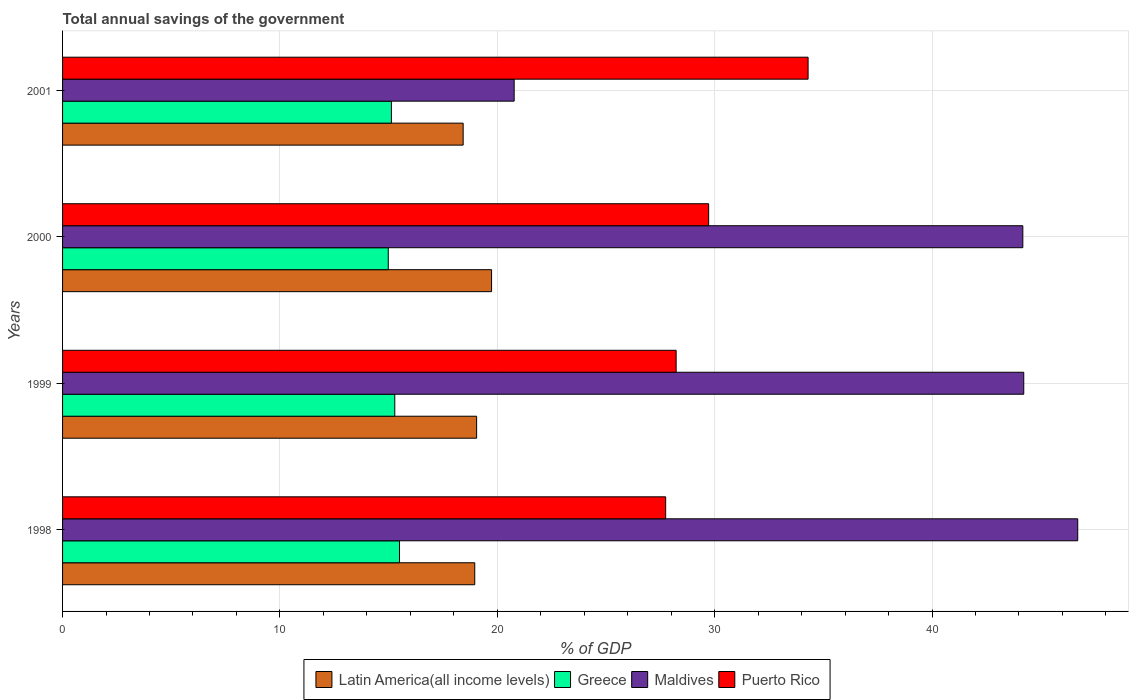How many groups of bars are there?
Your answer should be compact. 4. Are the number of bars per tick equal to the number of legend labels?
Give a very brief answer. Yes. How many bars are there on the 2nd tick from the bottom?
Offer a terse response. 4. What is the label of the 4th group of bars from the top?
Offer a terse response. 1998. What is the total annual savings of the government in Greece in 2000?
Your answer should be very brief. 14.98. Across all years, what is the maximum total annual savings of the government in Latin America(all income levels)?
Ensure brevity in your answer.  19.74. Across all years, what is the minimum total annual savings of the government in Latin America(all income levels)?
Your response must be concise. 18.43. What is the total total annual savings of the government in Greece in the graph?
Your response must be concise. 60.9. What is the difference between the total annual savings of the government in Puerto Rico in 1998 and that in 2000?
Provide a succinct answer. -1.98. What is the difference between the total annual savings of the government in Maldives in 1998 and the total annual savings of the government in Puerto Rico in 2001?
Offer a very short reply. 12.41. What is the average total annual savings of the government in Greece per year?
Your answer should be compact. 15.22. In the year 2000, what is the difference between the total annual savings of the government in Maldives and total annual savings of the government in Latin America(all income levels)?
Give a very brief answer. 24.44. What is the ratio of the total annual savings of the government in Greece in 1999 to that in 2000?
Make the answer very short. 1.02. Is the difference between the total annual savings of the government in Maldives in 1999 and 2001 greater than the difference between the total annual savings of the government in Latin America(all income levels) in 1999 and 2001?
Offer a very short reply. Yes. What is the difference between the highest and the second highest total annual savings of the government in Puerto Rico?
Provide a succinct answer. 4.57. What is the difference between the highest and the lowest total annual savings of the government in Puerto Rico?
Provide a short and direct response. 6.55. Is it the case that in every year, the sum of the total annual savings of the government in Latin America(all income levels) and total annual savings of the government in Maldives is greater than the sum of total annual savings of the government in Puerto Rico and total annual savings of the government in Greece?
Offer a terse response. Yes. What does the 3rd bar from the top in 2000 represents?
Provide a succinct answer. Greece. What does the 1st bar from the bottom in 1999 represents?
Give a very brief answer. Latin America(all income levels). Is it the case that in every year, the sum of the total annual savings of the government in Greece and total annual savings of the government in Puerto Rico is greater than the total annual savings of the government in Maldives?
Offer a terse response. No. How many bars are there?
Give a very brief answer. 16. Are all the bars in the graph horizontal?
Provide a succinct answer. Yes. How many years are there in the graph?
Ensure brevity in your answer.  4. Are the values on the major ticks of X-axis written in scientific E-notation?
Your answer should be very brief. No. Does the graph contain any zero values?
Give a very brief answer. No. Where does the legend appear in the graph?
Your response must be concise. Bottom center. What is the title of the graph?
Provide a short and direct response. Total annual savings of the government. What is the label or title of the X-axis?
Offer a very short reply. % of GDP. What is the % of GDP of Latin America(all income levels) in 1998?
Make the answer very short. 18.96. What is the % of GDP in Greece in 1998?
Provide a succinct answer. 15.5. What is the % of GDP in Maldives in 1998?
Provide a succinct answer. 46.7. What is the % of GDP of Puerto Rico in 1998?
Your answer should be compact. 27.75. What is the % of GDP in Latin America(all income levels) in 1999?
Your answer should be compact. 19.05. What is the % of GDP in Greece in 1999?
Ensure brevity in your answer.  15.28. What is the % of GDP of Maldives in 1999?
Ensure brevity in your answer.  44.22. What is the % of GDP in Puerto Rico in 1999?
Keep it short and to the point. 28.23. What is the % of GDP of Latin America(all income levels) in 2000?
Your response must be concise. 19.74. What is the % of GDP in Greece in 2000?
Offer a terse response. 14.98. What is the % of GDP in Maldives in 2000?
Your answer should be compact. 44.18. What is the % of GDP of Puerto Rico in 2000?
Keep it short and to the point. 29.72. What is the % of GDP in Latin America(all income levels) in 2001?
Offer a terse response. 18.43. What is the % of GDP of Greece in 2001?
Offer a terse response. 15.13. What is the % of GDP in Maldives in 2001?
Give a very brief answer. 20.78. What is the % of GDP of Puerto Rico in 2001?
Make the answer very short. 34.3. Across all years, what is the maximum % of GDP in Latin America(all income levels)?
Provide a succinct answer. 19.74. Across all years, what is the maximum % of GDP of Greece?
Keep it short and to the point. 15.5. Across all years, what is the maximum % of GDP of Maldives?
Keep it short and to the point. 46.7. Across all years, what is the maximum % of GDP of Puerto Rico?
Give a very brief answer. 34.3. Across all years, what is the minimum % of GDP in Latin America(all income levels)?
Offer a terse response. 18.43. Across all years, what is the minimum % of GDP in Greece?
Provide a succinct answer. 14.98. Across all years, what is the minimum % of GDP in Maldives?
Provide a short and direct response. 20.78. Across all years, what is the minimum % of GDP of Puerto Rico?
Offer a terse response. 27.75. What is the total % of GDP of Latin America(all income levels) in the graph?
Your answer should be compact. 76.18. What is the total % of GDP of Greece in the graph?
Offer a very short reply. 60.9. What is the total % of GDP of Maldives in the graph?
Give a very brief answer. 155.88. What is the total % of GDP in Puerto Rico in the graph?
Make the answer very short. 120. What is the difference between the % of GDP of Latin America(all income levels) in 1998 and that in 1999?
Your answer should be very brief. -0.09. What is the difference between the % of GDP in Greece in 1998 and that in 1999?
Offer a terse response. 0.22. What is the difference between the % of GDP in Maldives in 1998 and that in 1999?
Offer a very short reply. 2.48. What is the difference between the % of GDP in Puerto Rico in 1998 and that in 1999?
Offer a very short reply. -0.48. What is the difference between the % of GDP in Latin America(all income levels) in 1998 and that in 2000?
Give a very brief answer. -0.77. What is the difference between the % of GDP in Greece in 1998 and that in 2000?
Offer a very short reply. 0.52. What is the difference between the % of GDP in Maldives in 1998 and that in 2000?
Provide a succinct answer. 2.53. What is the difference between the % of GDP in Puerto Rico in 1998 and that in 2000?
Make the answer very short. -1.98. What is the difference between the % of GDP in Latin America(all income levels) in 1998 and that in 2001?
Make the answer very short. 0.53. What is the difference between the % of GDP of Greece in 1998 and that in 2001?
Ensure brevity in your answer.  0.37. What is the difference between the % of GDP of Maldives in 1998 and that in 2001?
Give a very brief answer. 25.93. What is the difference between the % of GDP in Puerto Rico in 1998 and that in 2001?
Keep it short and to the point. -6.55. What is the difference between the % of GDP of Latin America(all income levels) in 1999 and that in 2000?
Your answer should be very brief. -0.69. What is the difference between the % of GDP in Greece in 1999 and that in 2000?
Your answer should be very brief. 0.3. What is the difference between the % of GDP of Maldives in 1999 and that in 2000?
Your answer should be compact. 0.04. What is the difference between the % of GDP in Puerto Rico in 1999 and that in 2000?
Give a very brief answer. -1.5. What is the difference between the % of GDP in Latin America(all income levels) in 1999 and that in 2001?
Make the answer very short. 0.62. What is the difference between the % of GDP of Greece in 1999 and that in 2001?
Your answer should be compact. 0.16. What is the difference between the % of GDP in Maldives in 1999 and that in 2001?
Provide a succinct answer. 23.44. What is the difference between the % of GDP of Puerto Rico in 1999 and that in 2001?
Keep it short and to the point. -6.07. What is the difference between the % of GDP of Latin America(all income levels) in 2000 and that in 2001?
Make the answer very short. 1.31. What is the difference between the % of GDP of Greece in 2000 and that in 2001?
Your response must be concise. -0.14. What is the difference between the % of GDP of Maldives in 2000 and that in 2001?
Make the answer very short. 23.4. What is the difference between the % of GDP of Puerto Rico in 2000 and that in 2001?
Ensure brevity in your answer.  -4.57. What is the difference between the % of GDP of Latin America(all income levels) in 1998 and the % of GDP of Greece in 1999?
Your answer should be very brief. 3.68. What is the difference between the % of GDP in Latin America(all income levels) in 1998 and the % of GDP in Maldives in 1999?
Offer a very short reply. -25.26. What is the difference between the % of GDP in Latin America(all income levels) in 1998 and the % of GDP in Puerto Rico in 1999?
Your answer should be very brief. -9.27. What is the difference between the % of GDP in Greece in 1998 and the % of GDP in Maldives in 1999?
Ensure brevity in your answer.  -28.72. What is the difference between the % of GDP in Greece in 1998 and the % of GDP in Puerto Rico in 1999?
Give a very brief answer. -12.73. What is the difference between the % of GDP in Maldives in 1998 and the % of GDP in Puerto Rico in 1999?
Give a very brief answer. 18.48. What is the difference between the % of GDP of Latin America(all income levels) in 1998 and the % of GDP of Greece in 2000?
Offer a very short reply. 3.98. What is the difference between the % of GDP in Latin America(all income levels) in 1998 and the % of GDP in Maldives in 2000?
Offer a terse response. -25.21. What is the difference between the % of GDP in Latin America(all income levels) in 1998 and the % of GDP in Puerto Rico in 2000?
Give a very brief answer. -10.76. What is the difference between the % of GDP of Greece in 1998 and the % of GDP of Maldives in 2000?
Your answer should be compact. -28.68. What is the difference between the % of GDP in Greece in 1998 and the % of GDP in Puerto Rico in 2000?
Offer a terse response. -14.22. What is the difference between the % of GDP in Maldives in 1998 and the % of GDP in Puerto Rico in 2000?
Your answer should be compact. 16.98. What is the difference between the % of GDP in Latin America(all income levels) in 1998 and the % of GDP in Greece in 2001?
Ensure brevity in your answer.  3.83. What is the difference between the % of GDP of Latin America(all income levels) in 1998 and the % of GDP of Maldives in 2001?
Provide a succinct answer. -1.81. What is the difference between the % of GDP of Latin America(all income levels) in 1998 and the % of GDP of Puerto Rico in 2001?
Ensure brevity in your answer.  -15.34. What is the difference between the % of GDP in Greece in 1998 and the % of GDP in Maldives in 2001?
Your answer should be compact. -5.28. What is the difference between the % of GDP in Greece in 1998 and the % of GDP in Puerto Rico in 2001?
Ensure brevity in your answer.  -18.8. What is the difference between the % of GDP in Maldives in 1998 and the % of GDP in Puerto Rico in 2001?
Provide a succinct answer. 12.41. What is the difference between the % of GDP of Latin America(all income levels) in 1999 and the % of GDP of Greece in 2000?
Provide a short and direct response. 4.07. What is the difference between the % of GDP in Latin America(all income levels) in 1999 and the % of GDP in Maldives in 2000?
Offer a very short reply. -25.13. What is the difference between the % of GDP in Latin America(all income levels) in 1999 and the % of GDP in Puerto Rico in 2000?
Your answer should be compact. -10.68. What is the difference between the % of GDP in Greece in 1999 and the % of GDP in Maldives in 2000?
Keep it short and to the point. -28.89. What is the difference between the % of GDP of Greece in 1999 and the % of GDP of Puerto Rico in 2000?
Your answer should be compact. -14.44. What is the difference between the % of GDP in Maldives in 1999 and the % of GDP in Puerto Rico in 2000?
Keep it short and to the point. 14.5. What is the difference between the % of GDP in Latin America(all income levels) in 1999 and the % of GDP in Greece in 2001?
Your answer should be very brief. 3.92. What is the difference between the % of GDP in Latin America(all income levels) in 1999 and the % of GDP in Maldives in 2001?
Provide a short and direct response. -1.73. What is the difference between the % of GDP in Latin America(all income levels) in 1999 and the % of GDP in Puerto Rico in 2001?
Ensure brevity in your answer.  -15.25. What is the difference between the % of GDP in Greece in 1999 and the % of GDP in Maldives in 2001?
Your answer should be very brief. -5.49. What is the difference between the % of GDP of Greece in 1999 and the % of GDP of Puerto Rico in 2001?
Offer a very short reply. -19.01. What is the difference between the % of GDP of Maldives in 1999 and the % of GDP of Puerto Rico in 2001?
Keep it short and to the point. 9.92. What is the difference between the % of GDP of Latin America(all income levels) in 2000 and the % of GDP of Greece in 2001?
Your response must be concise. 4.61. What is the difference between the % of GDP of Latin America(all income levels) in 2000 and the % of GDP of Maldives in 2001?
Ensure brevity in your answer.  -1.04. What is the difference between the % of GDP of Latin America(all income levels) in 2000 and the % of GDP of Puerto Rico in 2001?
Keep it short and to the point. -14.56. What is the difference between the % of GDP of Greece in 2000 and the % of GDP of Maldives in 2001?
Your answer should be very brief. -5.79. What is the difference between the % of GDP of Greece in 2000 and the % of GDP of Puerto Rico in 2001?
Offer a very short reply. -19.31. What is the difference between the % of GDP of Maldives in 2000 and the % of GDP of Puerto Rico in 2001?
Give a very brief answer. 9.88. What is the average % of GDP of Latin America(all income levels) per year?
Your answer should be compact. 19.04. What is the average % of GDP of Greece per year?
Provide a succinct answer. 15.22. What is the average % of GDP of Maldives per year?
Make the answer very short. 38.97. What is the average % of GDP of Puerto Rico per year?
Offer a terse response. 30. In the year 1998, what is the difference between the % of GDP in Latin America(all income levels) and % of GDP in Greece?
Provide a short and direct response. 3.46. In the year 1998, what is the difference between the % of GDP in Latin America(all income levels) and % of GDP in Maldives?
Give a very brief answer. -27.74. In the year 1998, what is the difference between the % of GDP of Latin America(all income levels) and % of GDP of Puerto Rico?
Keep it short and to the point. -8.78. In the year 1998, what is the difference between the % of GDP of Greece and % of GDP of Maldives?
Make the answer very short. -31.2. In the year 1998, what is the difference between the % of GDP of Greece and % of GDP of Puerto Rico?
Provide a short and direct response. -12.25. In the year 1998, what is the difference between the % of GDP of Maldives and % of GDP of Puerto Rico?
Keep it short and to the point. 18.96. In the year 1999, what is the difference between the % of GDP of Latin America(all income levels) and % of GDP of Greece?
Your answer should be very brief. 3.76. In the year 1999, what is the difference between the % of GDP in Latin America(all income levels) and % of GDP in Maldives?
Ensure brevity in your answer.  -25.17. In the year 1999, what is the difference between the % of GDP of Latin America(all income levels) and % of GDP of Puerto Rico?
Make the answer very short. -9.18. In the year 1999, what is the difference between the % of GDP of Greece and % of GDP of Maldives?
Make the answer very short. -28.94. In the year 1999, what is the difference between the % of GDP of Greece and % of GDP of Puerto Rico?
Keep it short and to the point. -12.94. In the year 1999, what is the difference between the % of GDP in Maldives and % of GDP in Puerto Rico?
Provide a short and direct response. 15.99. In the year 2000, what is the difference between the % of GDP in Latin America(all income levels) and % of GDP in Greece?
Provide a short and direct response. 4.75. In the year 2000, what is the difference between the % of GDP of Latin America(all income levels) and % of GDP of Maldives?
Your answer should be compact. -24.44. In the year 2000, what is the difference between the % of GDP of Latin America(all income levels) and % of GDP of Puerto Rico?
Provide a succinct answer. -9.99. In the year 2000, what is the difference between the % of GDP in Greece and % of GDP in Maldives?
Your answer should be compact. -29.19. In the year 2000, what is the difference between the % of GDP of Greece and % of GDP of Puerto Rico?
Offer a very short reply. -14.74. In the year 2000, what is the difference between the % of GDP of Maldives and % of GDP of Puerto Rico?
Your response must be concise. 14.45. In the year 2001, what is the difference between the % of GDP of Latin America(all income levels) and % of GDP of Greece?
Provide a short and direct response. 3.3. In the year 2001, what is the difference between the % of GDP in Latin America(all income levels) and % of GDP in Maldives?
Your response must be concise. -2.35. In the year 2001, what is the difference between the % of GDP of Latin America(all income levels) and % of GDP of Puerto Rico?
Give a very brief answer. -15.87. In the year 2001, what is the difference between the % of GDP in Greece and % of GDP in Maldives?
Ensure brevity in your answer.  -5.65. In the year 2001, what is the difference between the % of GDP in Greece and % of GDP in Puerto Rico?
Your response must be concise. -19.17. In the year 2001, what is the difference between the % of GDP of Maldives and % of GDP of Puerto Rico?
Offer a terse response. -13.52. What is the ratio of the % of GDP of Latin America(all income levels) in 1998 to that in 1999?
Give a very brief answer. 1. What is the ratio of the % of GDP of Greece in 1998 to that in 1999?
Your answer should be very brief. 1.01. What is the ratio of the % of GDP in Maldives in 1998 to that in 1999?
Offer a very short reply. 1.06. What is the ratio of the % of GDP of Puerto Rico in 1998 to that in 1999?
Offer a very short reply. 0.98. What is the ratio of the % of GDP in Latin America(all income levels) in 1998 to that in 2000?
Ensure brevity in your answer.  0.96. What is the ratio of the % of GDP of Greece in 1998 to that in 2000?
Give a very brief answer. 1.03. What is the ratio of the % of GDP in Maldives in 1998 to that in 2000?
Your answer should be compact. 1.06. What is the ratio of the % of GDP in Puerto Rico in 1998 to that in 2000?
Offer a terse response. 0.93. What is the ratio of the % of GDP in Latin America(all income levels) in 1998 to that in 2001?
Make the answer very short. 1.03. What is the ratio of the % of GDP in Greece in 1998 to that in 2001?
Your answer should be compact. 1.02. What is the ratio of the % of GDP in Maldives in 1998 to that in 2001?
Offer a terse response. 2.25. What is the ratio of the % of GDP in Puerto Rico in 1998 to that in 2001?
Your answer should be very brief. 0.81. What is the ratio of the % of GDP of Latin America(all income levels) in 1999 to that in 2000?
Provide a short and direct response. 0.97. What is the ratio of the % of GDP of Greece in 1999 to that in 2000?
Offer a terse response. 1.02. What is the ratio of the % of GDP in Maldives in 1999 to that in 2000?
Offer a terse response. 1. What is the ratio of the % of GDP of Puerto Rico in 1999 to that in 2000?
Keep it short and to the point. 0.95. What is the ratio of the % of GDP in Latin America(all income levels) in 1999 to that in 2001?
Keep it short and to the point. 1.03. What is the ratio of the % of GDP in Greece in 1999 to that in 2001?
Your answer should be very brief. 1.01. What is the ratio of the % of GDP in Maldives in 1999 to that in 2001?
Make the answer very short. 2.13. What is the ratio of the % of GDP in Puerto Rico in 1999 to that in 2001?
Offer a terse response. 0.82. What is the ratio of the % of GDP in Latin America(all income levels) in 2000 to that in 2001?
Keep it short and to the point. 1.07. What is the ratio of the % of GDP in Greece in 2000 to that in 2001?
Provide a short and direct response. 0.99. What is the ratio of the % of GDP in Maldives in 2000 to that in 2001?
Your answer should be compact. 2.13. What is the ratio of the % of GDP in Puerto Rico in 2000 to that in 2001?
Provide a short and direct response. 0.87. What is the difference between the highest and the second highest % of GDP of Latin America(all income levels)?
Keep it short and to the point. 0.69. What is the difference between the highest and the second highest % of GDP of Greece?
Ensure brevity in your answer.  0.22. What is the difference between the highest and the second highest % of GDP in Maldives?
Give a very brief answer. 2.48. What is the difference between the highest and the second highest % of GDP in Puerto Rico?
Keep it short and to the point. 4.57. What is the difference between the highest and the lowest % of GDP in Latin America(all income levels)?
Your answer should be compact. 1.31. What is the difference between the highest and the lowest % of GDP in Greece?
Your response must be concise. 0.52. What is the difference between the highest and the lowest % of GDP of Maldives?
Give a very brief answer. 25.93. What is the difference between the highest and the lowest % of GDP of Puerto Rico?
Give a very brief answer. 6.55. 